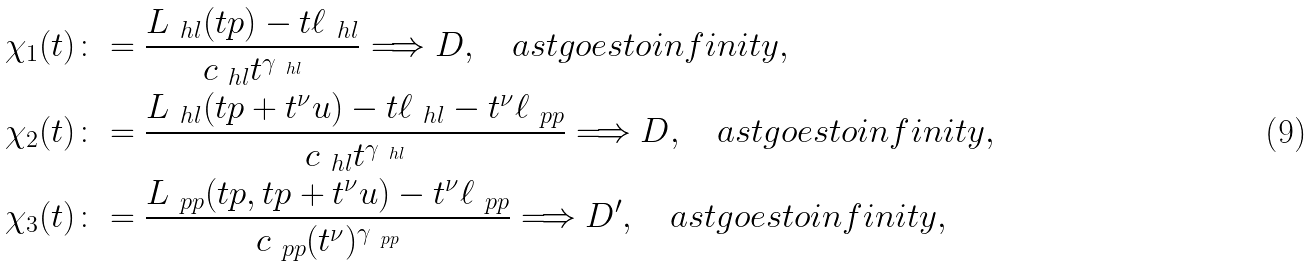<formula> <loc_0><loc_0><loc_500><loc_500>\chi _ { 1 } ( t ) & \colon = \frac { L _ { \ h l } ( t p ) - t \ell _ { \ h l } } { c _ { \ h l } t ^ { \gamma _ { \ h l } } } \Longrightarrow D , \quad a s t g o e s t o i n f i n i t y , \\ \chi _ { 2 } ( t ) & \colon = \frac { L _ { \ h l } ( t p + t ^ { \nu } u ) - t \ell _ { \ h l } - t ^ { \nu } \ell _ { \ p p } } { c _ { \ h l } t ^ { \gamma _ { \ h l } } } \Longrightarrow D , \quad a s t g o e s t o i n f i n i t y , \\ \chi _ { 3 } ( t ) & \colon = \frac { L _ { \ p p } ( t p , t p + t ^ { \nu } u ) - t ^ { \nu } \ell _ { \ p p } } { c _ { \ p p } ( t ^ { \nu } ) ^ { \gamma _ { \ p p } } } \Longrightarrow D ^ { \prime } , \quad a s t g o e s t o i n f i n i t y ,</formula> 